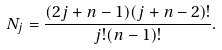Convert formula to latex. <formula><loc_0><loc_0><loc_500><loc_500>N _ { j } = \frac { ( 2 j + n - 1 ) ( j + n - 2 ) ! } { j ! ( n - 1 ) ! } .</formula> 